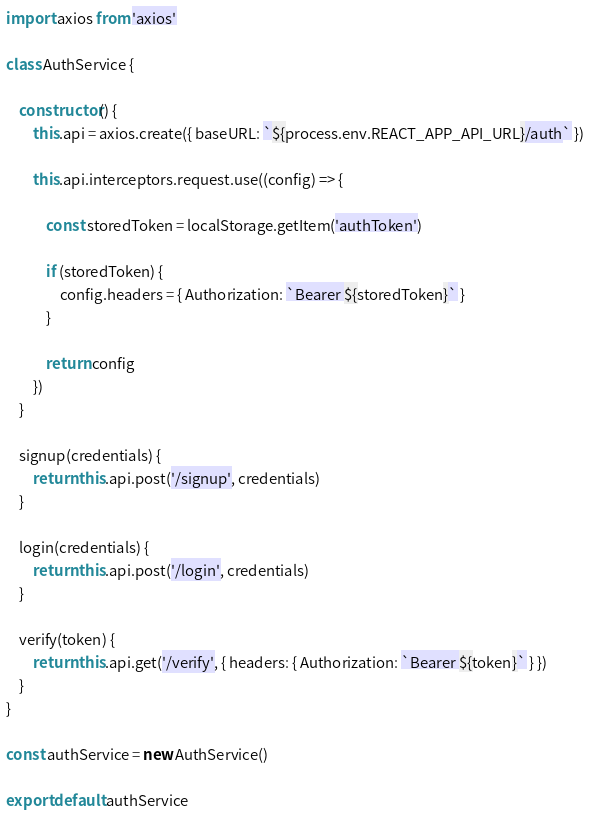<code> <loc_0><loc_0><loc_500><loc_500><_JavaScript_>import axios from 'axios'

class AuthService {

    constructor() {
        this.api = axios.create({ baseURL: `${process.env.REACT_APP_API_URL}/auth` })

        this.api.interceptors.request.use((config) => {

            const storedToken = localStorage.getItem('authToken')
        
            if (storedToken) {
                config.headers = { Authorization: `Bearer ${storedToken}` }
            }
        
            return config
        })
    }

    signup(credentials) {
        return this.api.post('/signup', credentials)
    }

    login(credentials) {
        return this.api.post('/login', credentials)
    }

    verify(token) {
        return this.api.get('/verify', { headers: { Authorization: `Bearer ${token}` } })
    }
}

const authService = new AuthService()

export default authService</code> 